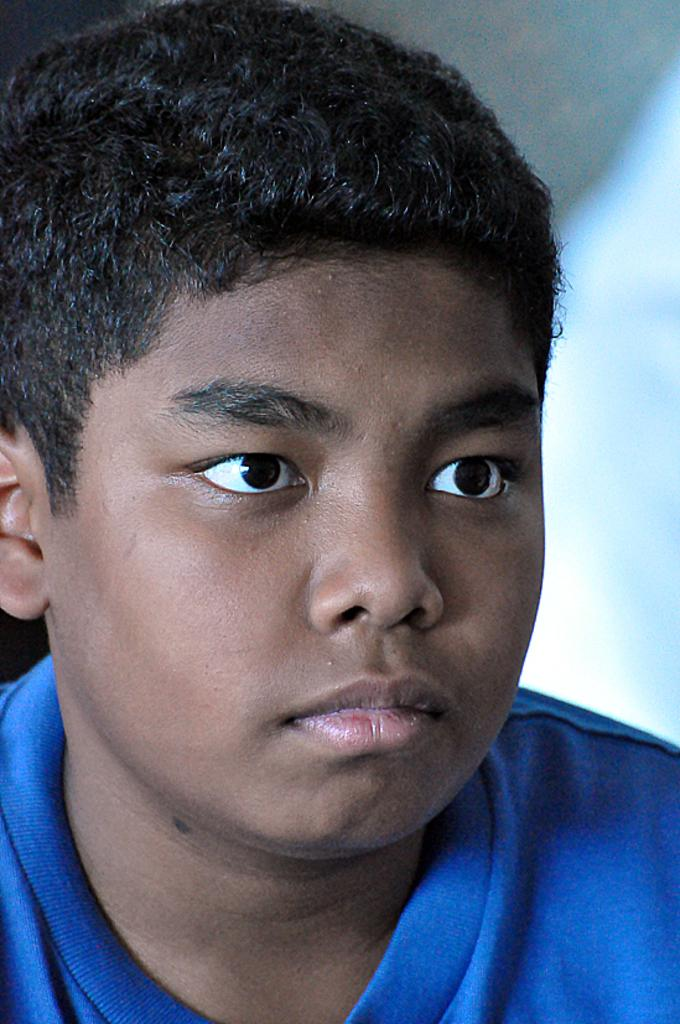What is the main subject in the foreground of the image? There is a person in the foreground of the image. What is the person wearing in the image? The person is wearing a blue dress in the image. What color is the background of the image? The background of the image is white in color. What route does the police officer take in the image? There is no police officer present in the image, so there is no route to discuss. 